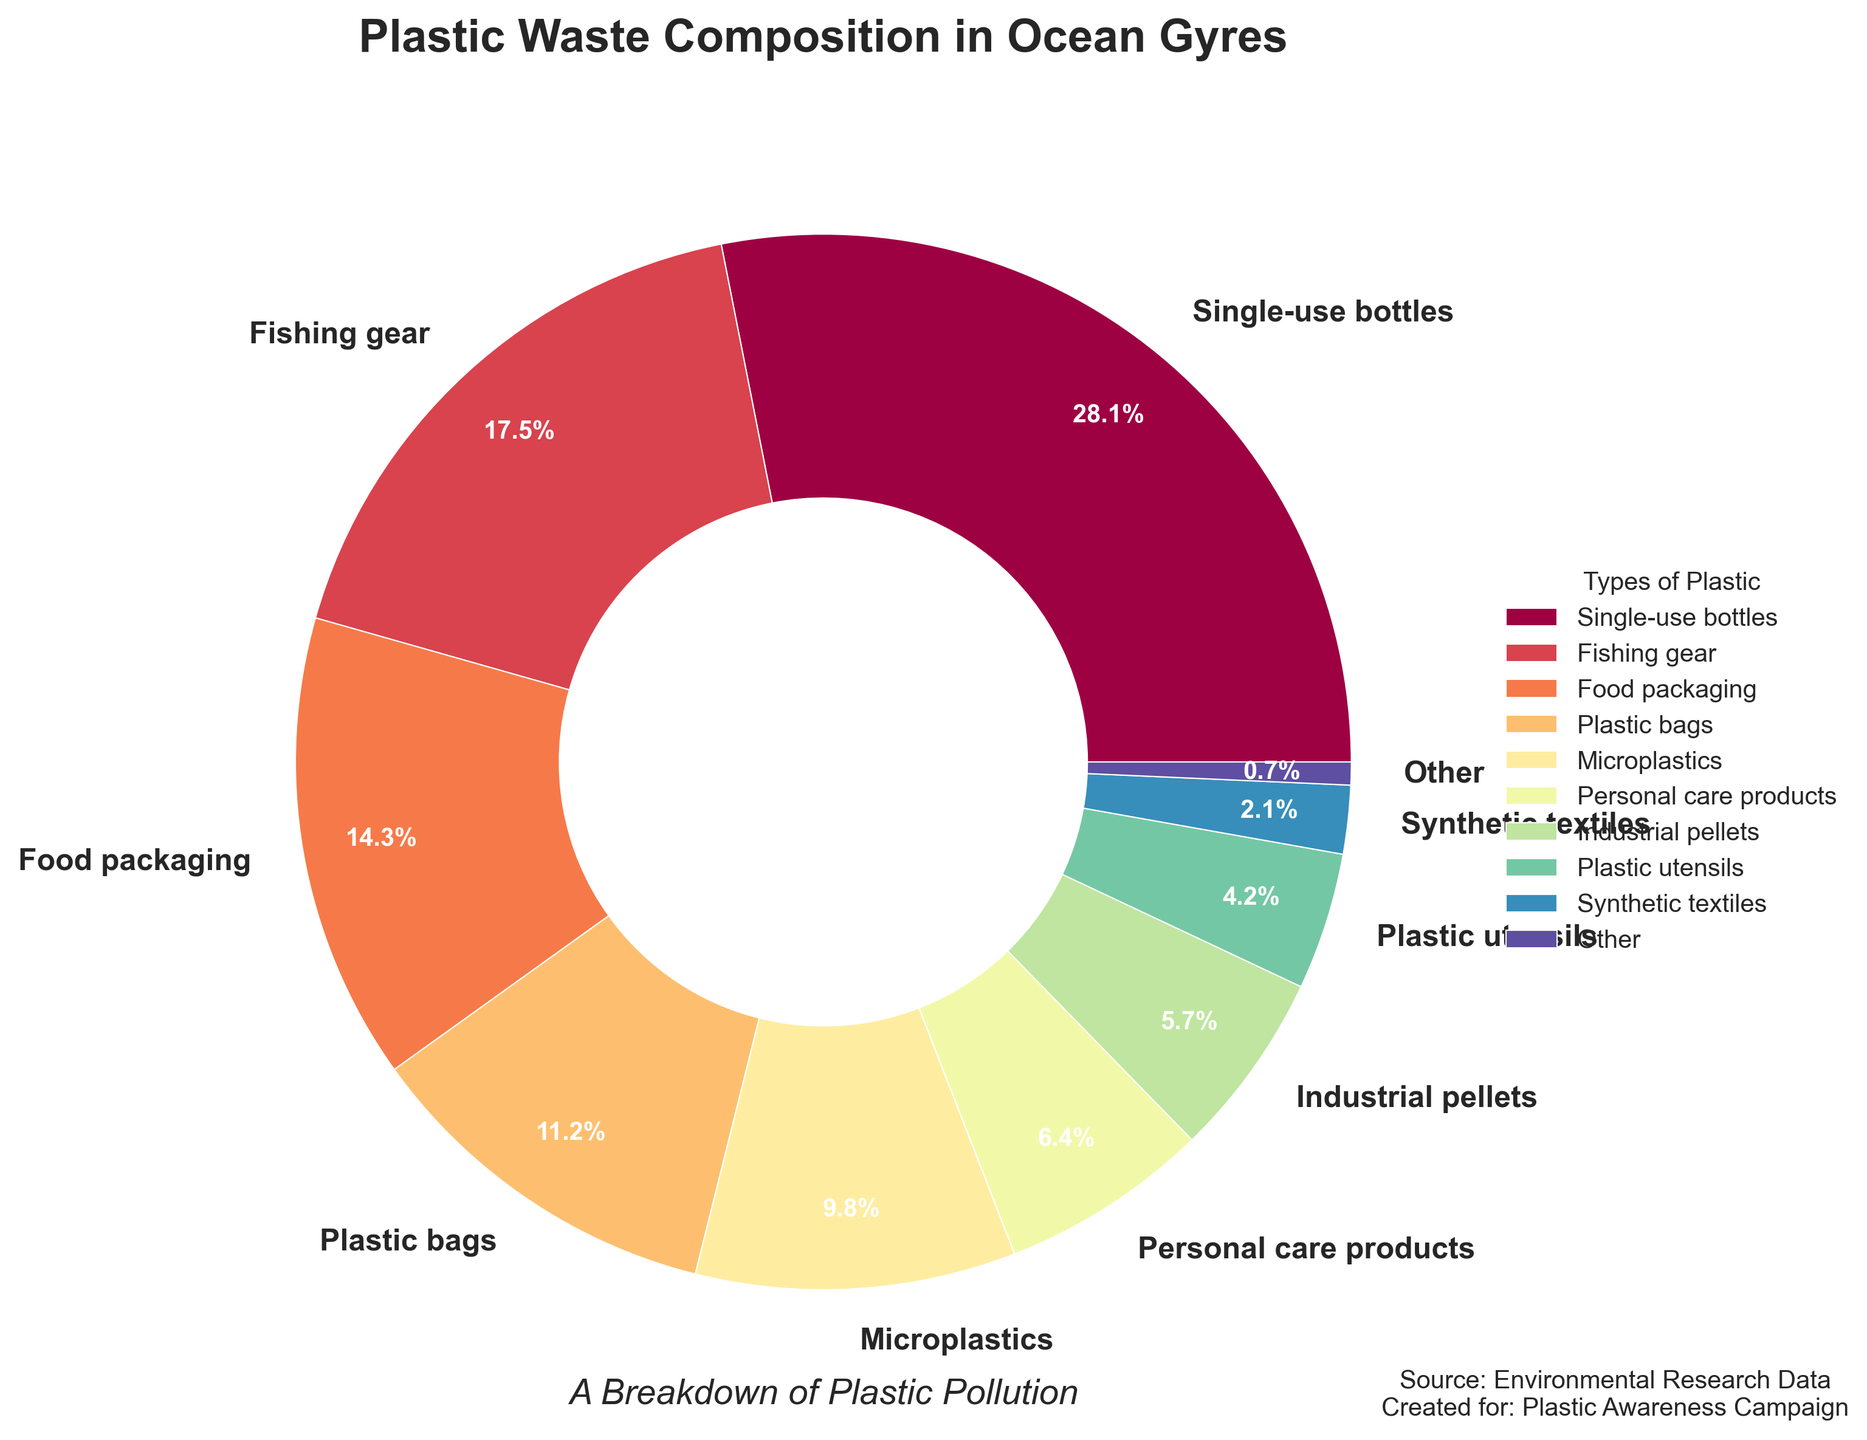Which category of plastic waste has the highest percentage? The pie chart shows that 'Single-use bottles' has the highest percentage at 28.1%.
Answer: Single-use bottles What is the combined percentage of 'Plastic bags' and 'Plastic utensils'? The pie chart indicates 'Plastic bags' at 11.2% and 'Plastic utensils' at 4.2%. Adding these gives 11.2% + 4.2% = 15.4%.
Answer: 15.4% Is the percentage of 'Fishing gear' greater than 'Food packaging'? The pie chart shows 'Fishing gear' at 17.5% and 'Food packaging' at 14.3%. Since 17.5% > 14.3%, 'Fishing gear' has a greater percentage.
Answer: Yes What is the percentage difference between 'Single-use bottles' and 'Microplastics'? 'Single-use bottles' have 28.1% while 'Microplastics' have 9.8%. The difference is 28.1% - 9.8% = 18.3%.
Answer: 18.3% Which categories have percentages less than 10%? Categories under 10% on the pie chart are 'Microplastics' at 9.8%, 'Personal care products' at 6.4%, 'Industrial pellets' at 5.7%, 'Plastic utensils' at 4.2%, 'Synthetic textiles' at 2.1%, and 'Other' at 0.7%.
Answer: Microplastics, Personal care products, Industrial pellets, Plastic utensils, Synthetic textiles, Other How does the percentage of 'Personal care products' compare to that of 'Industrial pellets'? The pie chart shows 'Personal care products' at 6.4% and 'Industrial pellets' at 5.7%. Since 6.4% > 5.7%, 'Personal care products' have a higher percentage.
Answer: Higher Identify the type of plastic with the smallest percentage and specify its value. The pie chart indicates 'Other' as the category with the smallest percentage at 0.7%.
Answer: Other, 0.7% What is the total percentage summed from 'Single-use bottles', 'Fishing gear', and 'Food packaging'? The pie chart shows 'Single-use bottles' at 28.1%, 'Fishing gear' at 17.5%, and 'Food packaging' at 14.3%. Summing these gives 28.1% + 17.5% + 14.3% = 59.9%.
Answer: 59.9% Do 'Synthetic textiles' and 'Plastic utensils' collectively amount to more than 'Food packaging'? The pie chart shows 'Synthetic textiles' at 2.1% and 'Plastic utensils' at 4.2%; collectively they make 2.1% + 4.2% = 6.3%. 'Food packaging' is 14.3%, so 6.3% < 14.3%.
Answer: No 